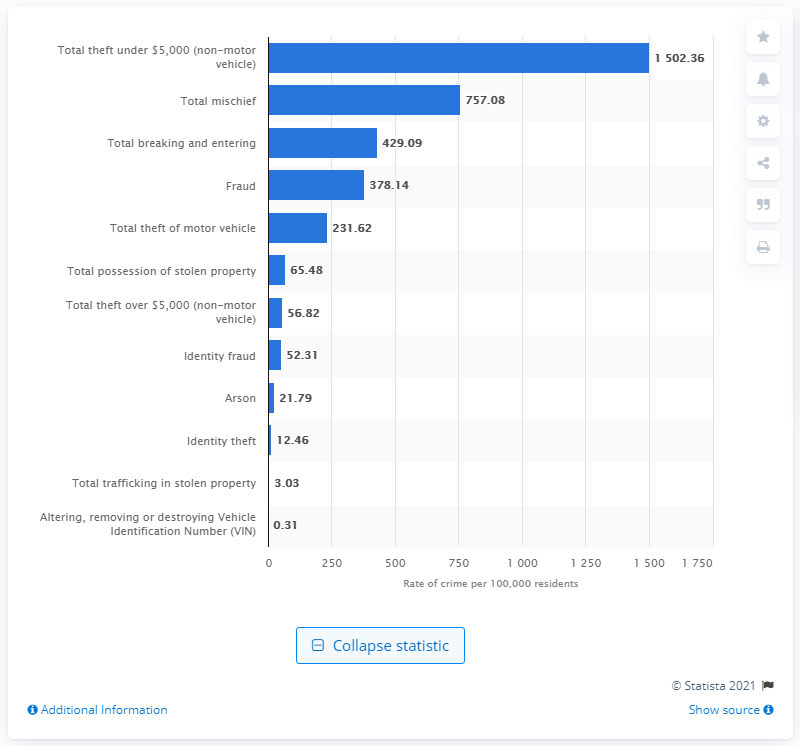Which type of crime reported in Canada for 2019 had the lowest rate per 100,000 residents? The type of crime reported in Canada for 2019 that had the lowest rate per 100,000 residents was 'Altering, removing or destroying Vehicle Identification Number (VIN)' with a rate of 0.31 incidents. 